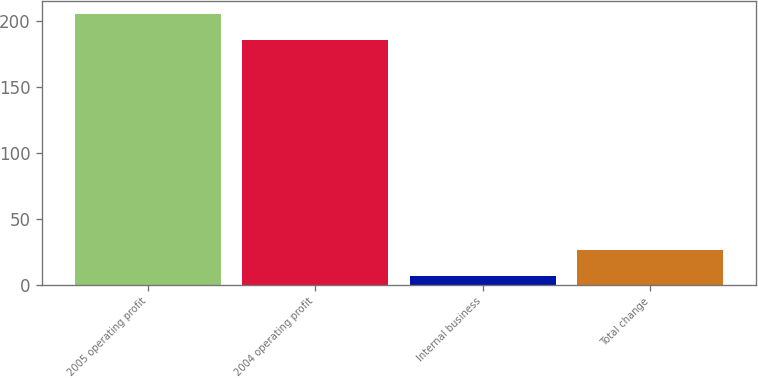Convert chart to OTSL. <chart><loc_0><loc_0><loc_500><loc_500><bar_chart><fcel>2005 operating profit<fcel>2004 operating profit<fcel>Internal business<fcel>Total change<nl><fcel>205.02<fcel>185.4<fcel>6.6<fcel>26.22<nl></chart> 